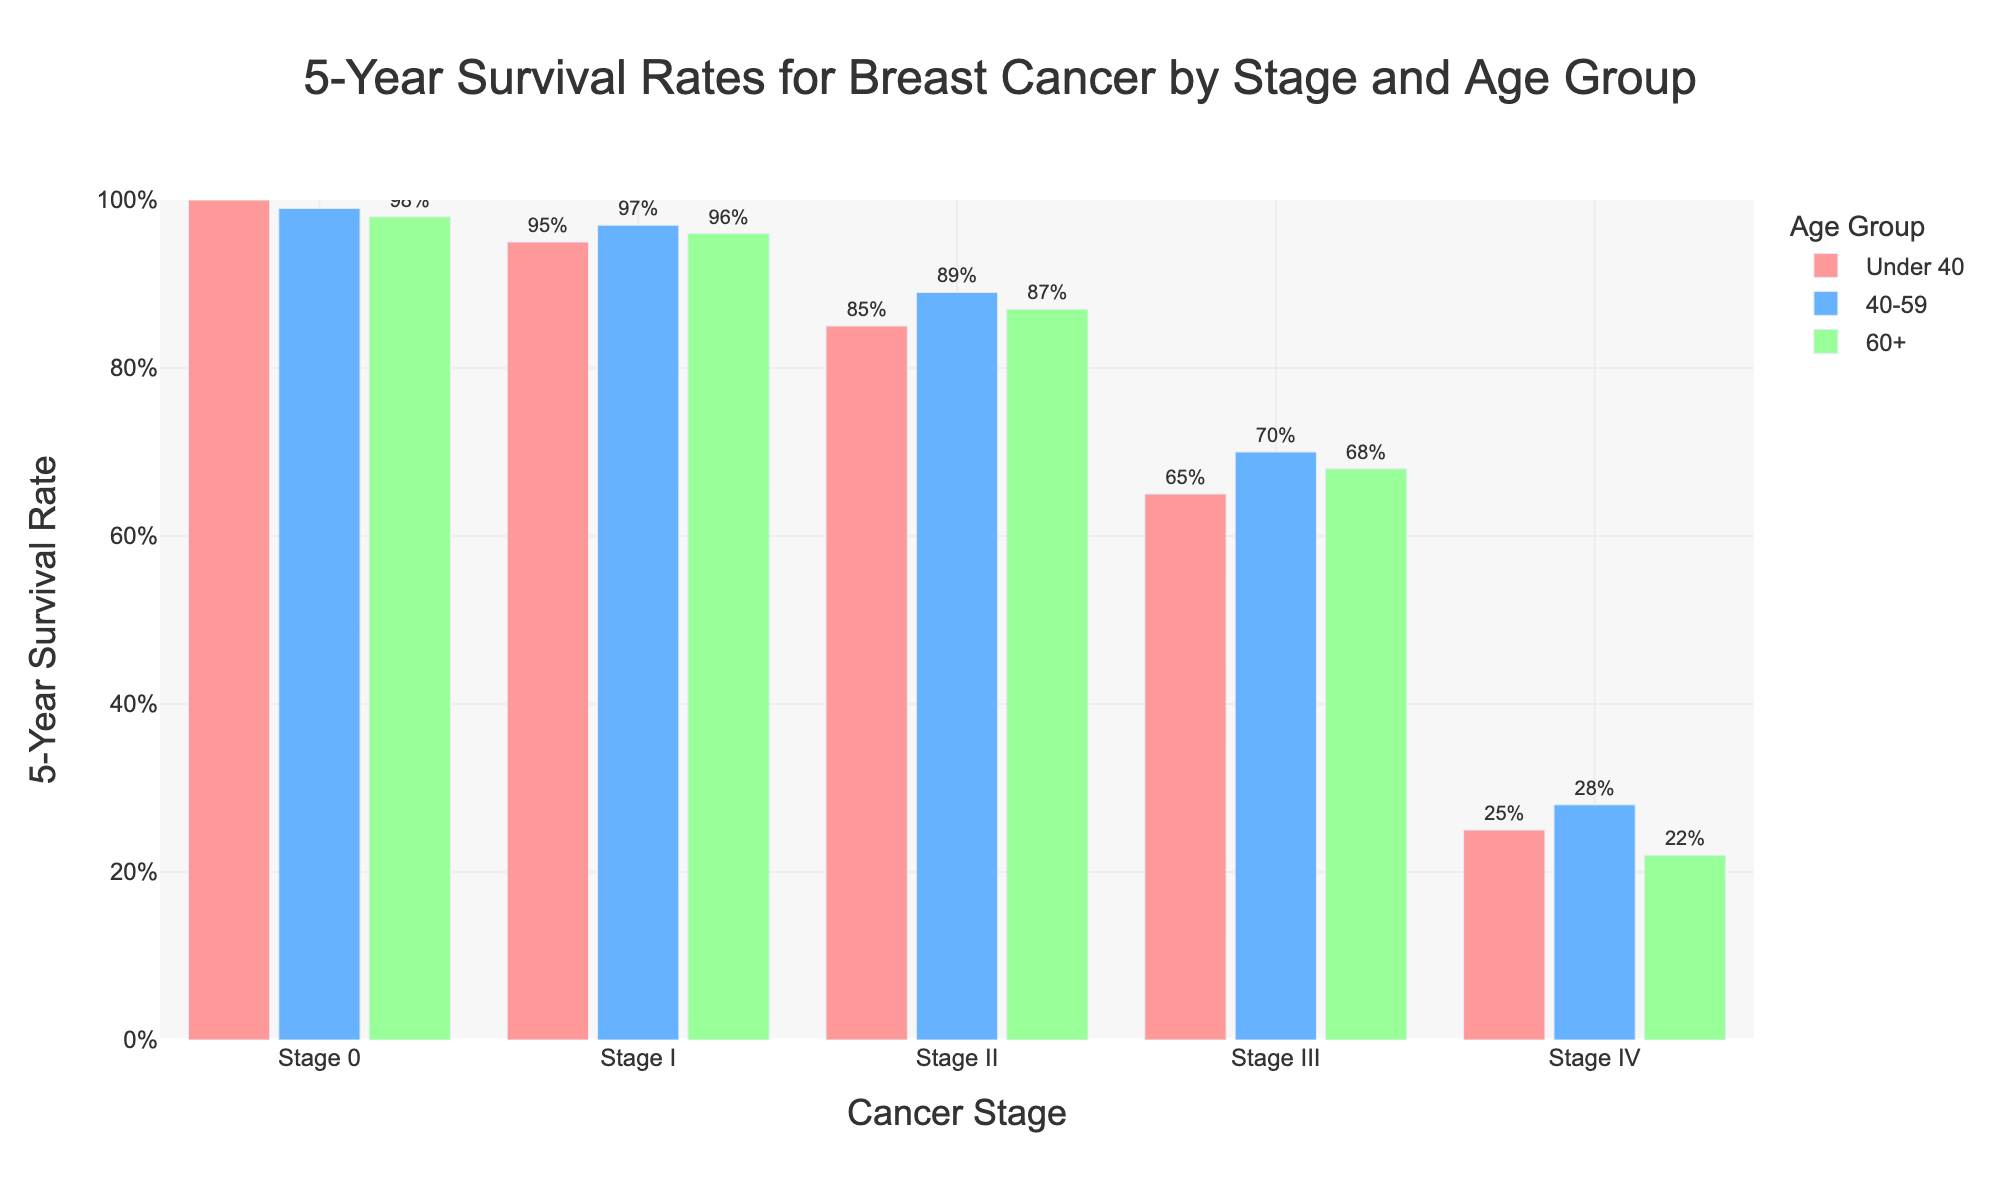Which age group has the highest 5-year survival rate for Stage II breast cancer? To determine this, we compare the 5-year survival rates for Stage II across different age groups. Under 40 has 85%, 40-59 has 89%, and 60+ has 87%. The highest rate is 89% in the 40-59 age group.
Answer: 40-59 How much lower is the 5-year survival rate for Stage IV compared to Stage I in the Under 40 age group? The survival rate for Stage I under 40 is 95% and for Stage IV under 40 is 25%. The difference is 95% - 25% = 70%.
Answer: 70% What is the average 5-year survival rate for Stage III breast cancer across all age groups? The rates for Stage III are 65% (Under 40), 70% (40-59), and 68% (60+). To find the average: (65 + 70 + 68) / 3 = 67.67%.
Answer: 67.67% Which stage shows the smallest difference in 5-year survival rates between the 40-59 and 60+ age groups? We compare the survival rate differences for each stage: Stage 0 (99% - 98% = 1%), Stage I (97% - 96% = 1%), Stage II (89% - 87% = 2%), Stage III (70% - 68% = 2%), Stage IV (28% - 22% = 6%). The smallest differences are in Stage 0 and Stage I, both with a 1% difference.
Answer: Stage 0 and Stage I For the Stage II diagnosis, what is the ratio of the survival rate of the 40-59 age group to the Under 40 age group? The Stage II survival rate for the 40-59 age group is 89%, and for the Under 40 age group, it is 85%. The ratio is 89% / 85% = 1.047.
Answer: 1.047 In which stage does the survival rate decrease more drastically when comparing between Under 40 and 60+ age groups? To find the most drastic decrease, compare the differences for each stage: Stage 0 (100% - 98% = 2%), Stage I (95% - 96% = -1%), Stage II (85% - 87% = -2%), Stage III (65% - 68% = -3%), Stage IV (25% - 22% = 3%). The most drastic decrease is 40-22% at Stage IV.
Answer: Stage IV How do the survival rates for Stage I differ with age group progression from Under 40 to 60+? The 5-year survival rates for Stage I are 95% for Under 40, 97% for 40-59, and 96% for 60+. The progression shows a slight increase to 97% and then a small decrease to 96%.
Answer: Increase then decrease 